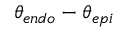Convert formula to latex. <formula><loc_0><loc_0><loc_500><loc_500>\theta _ { e n d o } - \theta _ { e p i }</formula> 